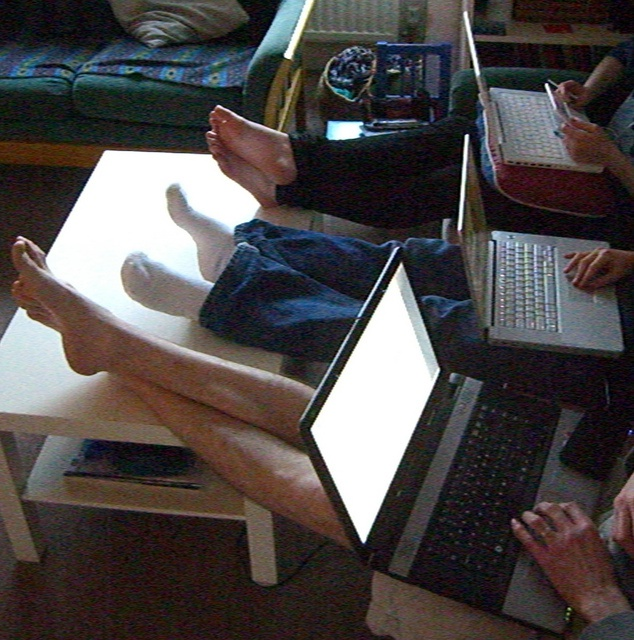Describe the objects in this image and their specific colors. I can see laptop in black, white, and gray tones, couch in black, blue, gray, and maroon tones, people in black, navy, gray, and darkgray tones, people in black, maroon, brown, and darkgray tones, and people in black, brown, and maroon tones in this image. 